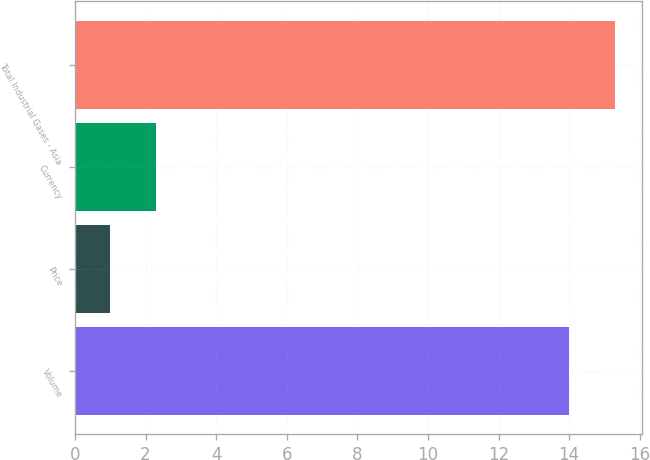<chart> <loc_0><loc_0><loc_500><loc_500><bar_chart><fcel>Volume<fcel>Price<fcel>Currency<fcel>Total Industrial Gases - Asia<nl><fcel>14<fcel>1<fcel>2.3<fcel>15.3<nl></chart> 